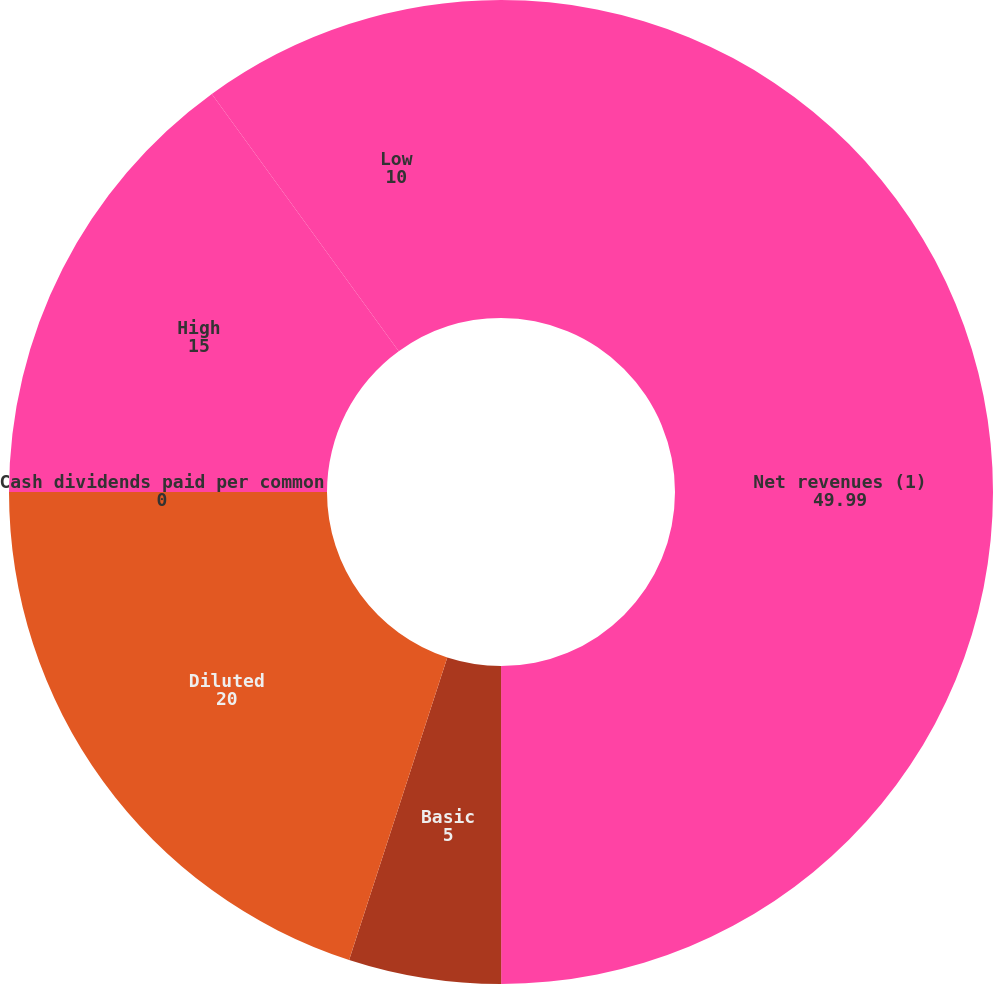<chart> <loc_0><loc_0><loc_500><loc_500><pie_chart><fcel>Net revenues (1)<fcel>Basic<fcel>Diluted<fcel>Cash dividends paid per common<fcel>High<fcel>Low<nl><fcel>49.99%<fcel>5.0%<fcel>20.0%<fcel>0.0%<fcel>15.0%<fcel>10.0%<nl></chart> 